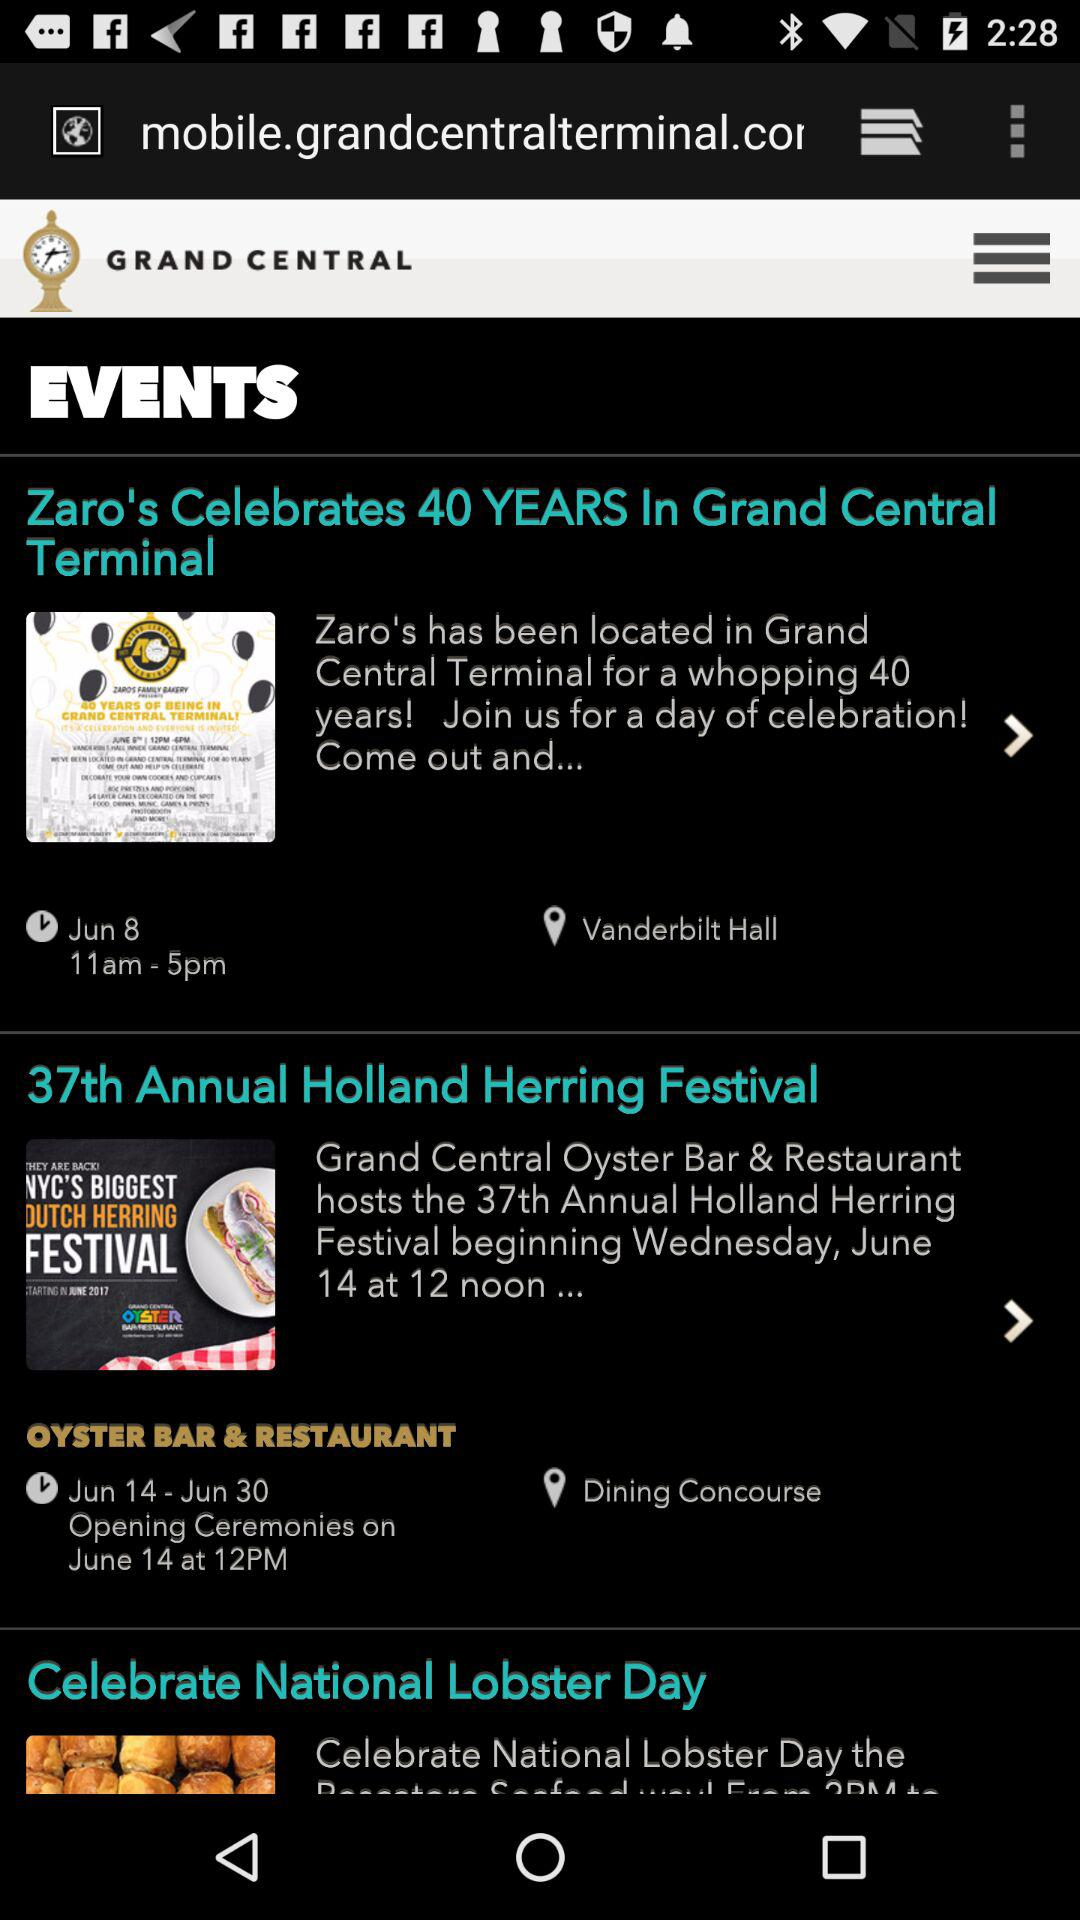What is "Zaro's Celebrates 40 Years" event timing? "Zaro's Celebrates 40 Years" event timing from 11 am to 5 pm. 